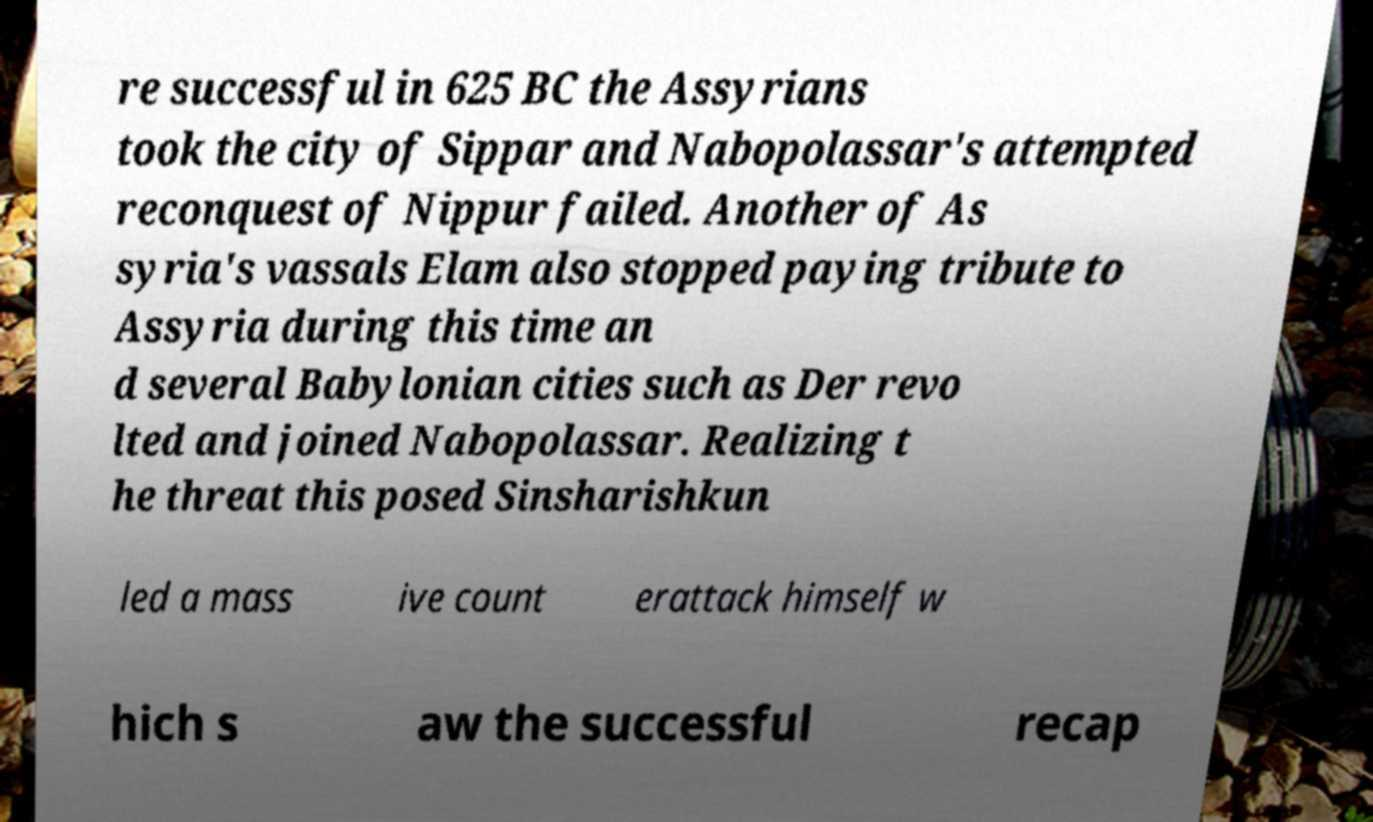There's text embedded in this image that I need extracted. Can you transcribe it verbatim? re successful in 625 BC the Assyrians took the city of Sippar and Nabopolassar's attempted reconquest of Nippur failed. Another of As syria's vassals Elam also stopped paying tribute to Assyria during this time an d several Babylonian cities such as Der revo lted and joined Nabopolassar. Realizing t he threat this posed Sinsharishkun led a mass ive count erattack himself w hich s aw the successful recap 